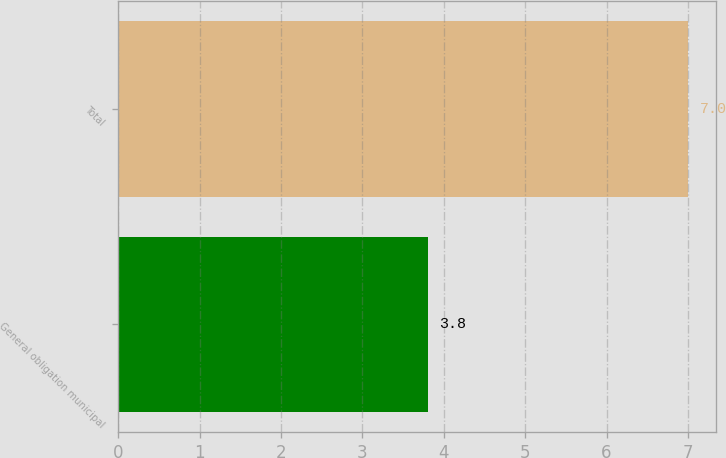Convert chart to OTSL. <chart><loc_0><loc_0><loc_500><loc_500><bar_chart><fcel>General obligation municipal<fcel>Total<nl><fcel>3.8<fcel>7<nl></chart> 